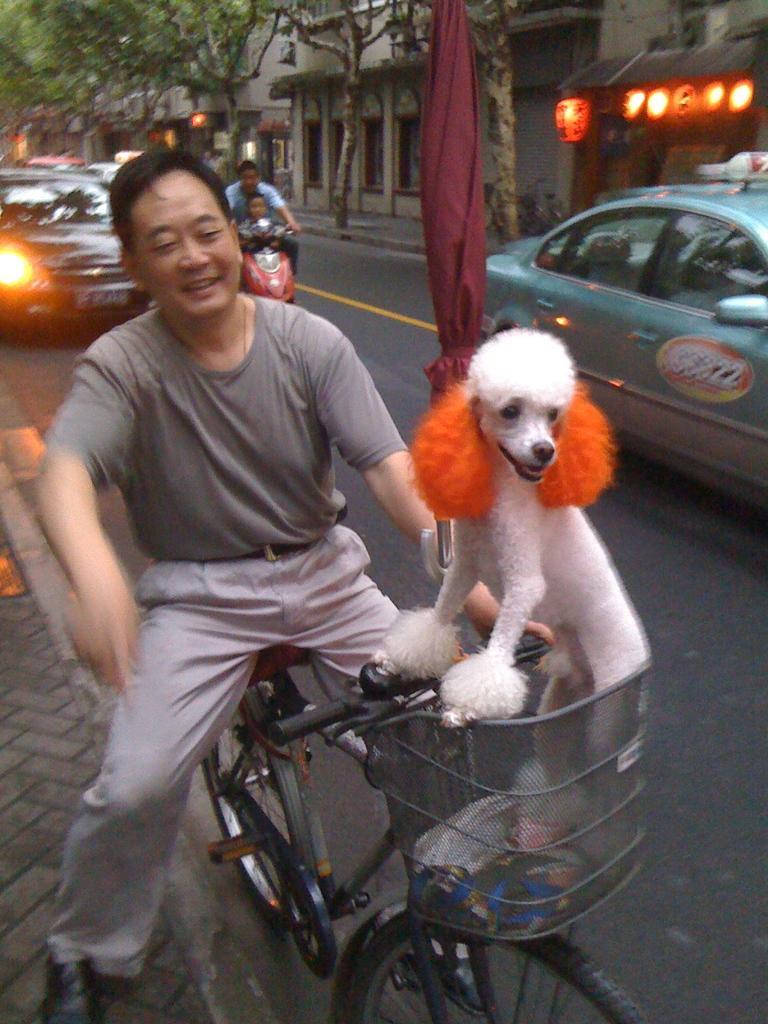Could you give a brief overview of what you see in this image? In this image we can see a man on the bicycle and a dog in the basket. In the background we can see a car, bike, buildings and trees. 